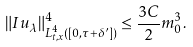<formula> <loc_0><loc_0><loc_500><loc_500>\| I u _ { \lambda } \| _ { L _ { t , x } ^ { 4 } ( [ 0 , \tau + \delta ^ { \prime } ] ) } ^ { 4 } \leq \frac { 3 C } { 2 } m _ { 0 } ^ { 3 } .</formula> 